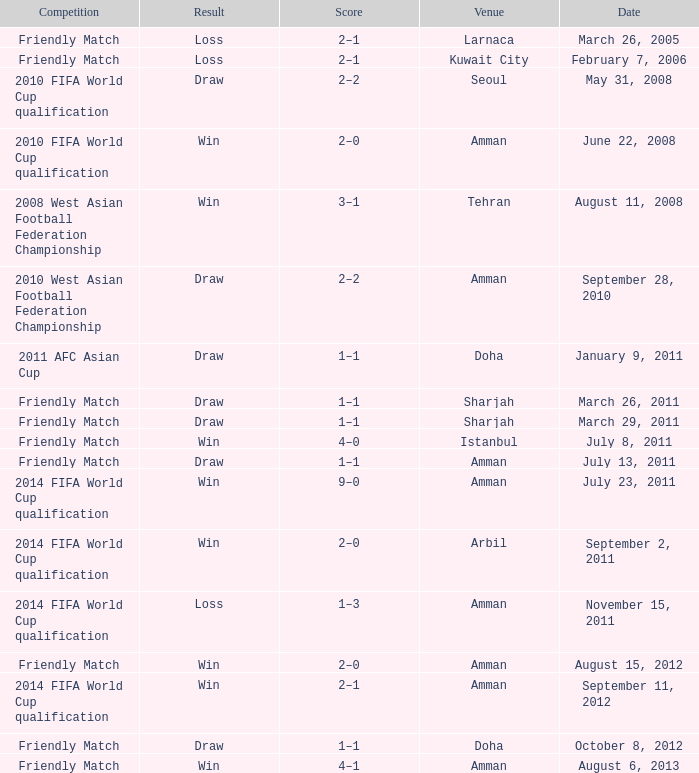WHat was the result of the friendly match that was played on october 8, 2012? Draw. Parse the table in full. {'header': ['Competition', 'Result', 'Score', 'Venue', 'Date'], 'rows': [['Friendly Match', 'Loss', '2–1', 'Larnaca', 'March 26, 2005'], ['Friendly Match', 'Loss', '2–1', 'Kuwait City', 'February 7, 2006'], ['2010 FIFA World Cup qualification', 'Draw', '2–2', 'Seoul', 'May 31, 2008'], ['2010 FIFA World Cup qualification', 'Win', '2–0', 'Amman', 'June 22, 2008'], ['2008 West Asian Football Federation Championship', 'Win', '3–1', 'Tehran', 'August 11, 2008'], ['2010 West Asian Football Federation Championship', 'Draw', '2–2', 'Amman', 'September 28, 2010'], ['2011 AFC Asian Cup', 'Draw', '1–1', 'Doha', 'January 9, 2011'], ['Friendly Match', 'Draw', '1–1', 'Sharjah', 'March 26, 2011'], ['Friendly Match', 'Draw', '1–1', 'Sharjah', 'March 29, 2011'], ['Friendly Match', 'Win', '4–0', 'Istanbul', 'July 8, 2011'], ['Friendly Match', 'Draw', '1–1', 'Amman', 'July 13, 2011'], ['2014 FIFA World Cup qualification', 'Win', '9–0', 'Amman', 'July 23, 2011'], ['2014 FIFA World Cup qualification', 'Win', '2–0', 'Arbil', 'September 2, 2011'], ['2014 FIFA World Cup qualification', 'Loss', '1–3', 'Amman', 'November 15, 2011'], ['Friendly Match', 'Win', '2–0', 'Amman', 'August 15, 2012'], ['2014 FIFA World Cup qualification', 'Win', '2–1', 'Amman', 'September 11, 2012'], ['Friendly Match', 'Draw', '1–1', 'Doha', 'October 8, 2012'], ['Friendly Match', 'Win', '4–1', 'Amman', 'August 6, 2013']]} 